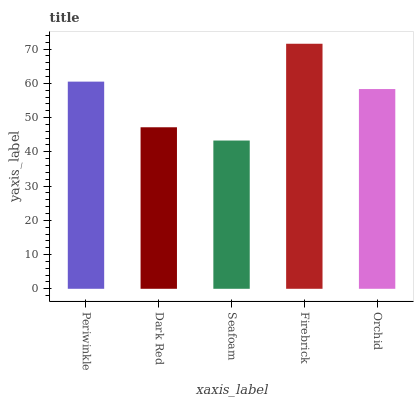Is Seafoam the minimum?
Answer yes or no. Yes. Is Firebrick the maximum?
Answer yes or no. Yes. Is Dark Red the minimum?
Answer yes or no. No. Is Dark Red the maximum?
Answer yes or no. No. Is Periwinkle greater than Dark Red?
Answer yes or no. Yes. Is Dark Red less than Periwinkle?
Answer yes or no. Yes. Is Dark Red greater than Periwinkle?
Answer yes or no. No. Is Periwinkle less than Dark Red?
Answer yes or no. No. Is Orchid the high median?
Answer yes or no. Yes. Is Orchid the low median?
Answer yes or no. Yes. Is Seafoam the high median?
Answer yes or no. No. Is Dark Red the low median?
Answer yes or no. No. 